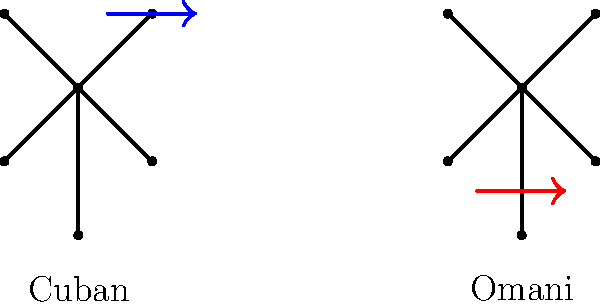Based on the stick figure illustrations comparing traditional Cuban and Omani dance movements, which key difference can be observed in the primary focus of movement between the two dance styles? To answer this question, let's analyze the stick figure illustrations step-by-step:

1. Cuban dancer:
   - The stick figure on the left represents a Cuban dancer.
   - There's a blue arrow pointing horizontally near the upper body.
   - This suggests that Cuban dance movements often emphasize upper body motion.

2. Omani dancer:
   - The stick figure on the right represents an Omani dancer.
   - There's a red arrow pointing horizontally near the lower body.
   - This indicates that Omani dance movements tend to focus more on lower body motion.

3. Comparison:
   - The key difference lies in the placement of the arrows, which represent the primary focus of movement in each dance style.
   - The Cuban dancer's arrow is near the shoulders, suggesting upper body emphasis.
   - The Omani dancer's arrow is near the feet, indicating lower body focus.

4. Cultural context:
   - Cuban dances, like salsa and rumba, often involve intricate upper body movements, arm patterns, and shoulder shimmies.
   - Omani traditional dances, such as Al-Bar'ah and Al-Razha, typically feature strong footwork and lower body movements.

Based on this analysis, we can conclude that the key difference in the primary focus of movement between Cuban and Omani dance styles is the emphasis on upper body versus lower body movements, respectively.
Answer: Upper body (Cuban) vs. lower body (Omani) movement focus 